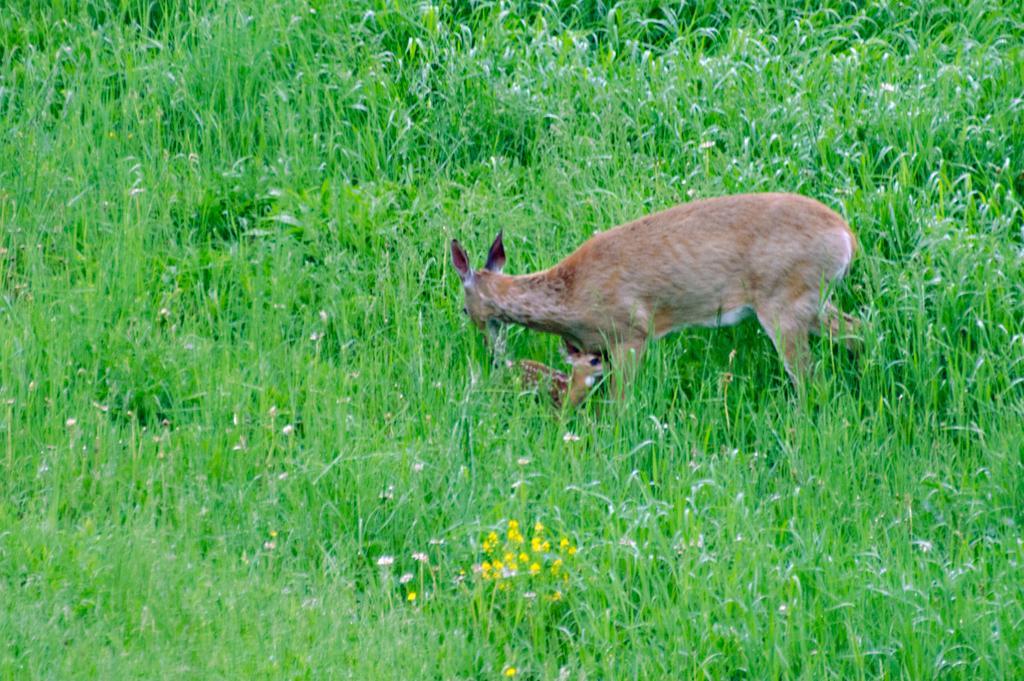In one or two sentences, can you explain what this image depicts? In this picture I can observe a deer walking on the ground. I can observe some grass in this picture. There are yellow color flowers on the bottom of the picture. 